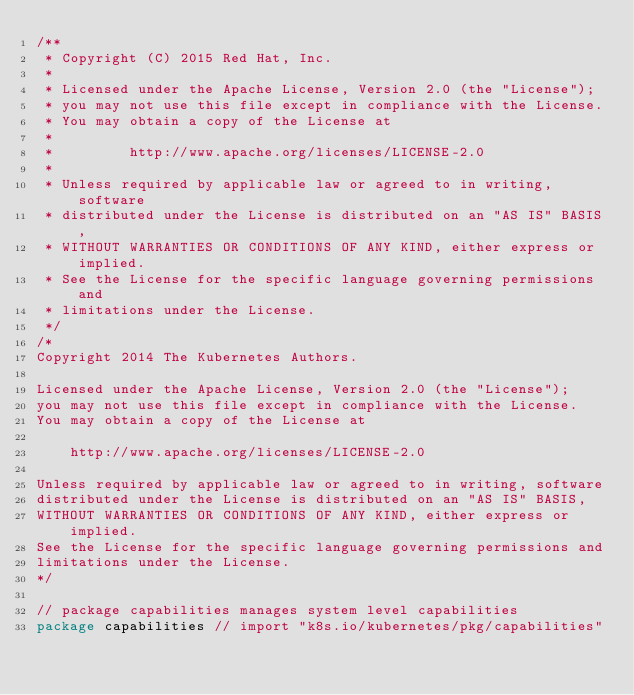<code> <loc_0><loc_0><loc_500><loc_500><_Go_>/**
 * Copyright (C) 2015 Red Hat, Inc.
 *
 * Licensed under the Apache License, Version 2.0 (the "License");
 * you may not use this file except in compliance with the License.
 * You may obtain a copy of the License at
 *
 *         http://www.apache.org/licenses/LICENSE-2.0
 *
 * Unless required by applicable law or agreed to in writing, software
 * distributed under the License is distributed on an "AS IS" BASIS,
 * WITHOUT WARRANTIES OR CONDITIONS OF ANY KIND, either express or implied.
 * See the License for the specific language governing permissions and
 * limitations under the License.
 */
/*
Copyright 2014 The Kubernetes Authors.

Licensed under the Apache License, Version 2.0 (the "License");
you may not use this file except in compliance with the License.
You may obtain a copy of the License at

    http://www.apache.org/licenses/LICENSE-2.0

Unless required by applicable law or agreed to in writing, software
distributed under the License is distributed on an "AS IS" BASIS,
WITHOUT WARRANTIES OR CONDITIONS OF ANY KIND, either express or implied.
See the License for the specific language governing permissions and
limitations under the License.
*/

// package capabilities manages system level capabilities
package capabilities // import "k8s.io/kubernetes/pkg/capabilities"
</code> 